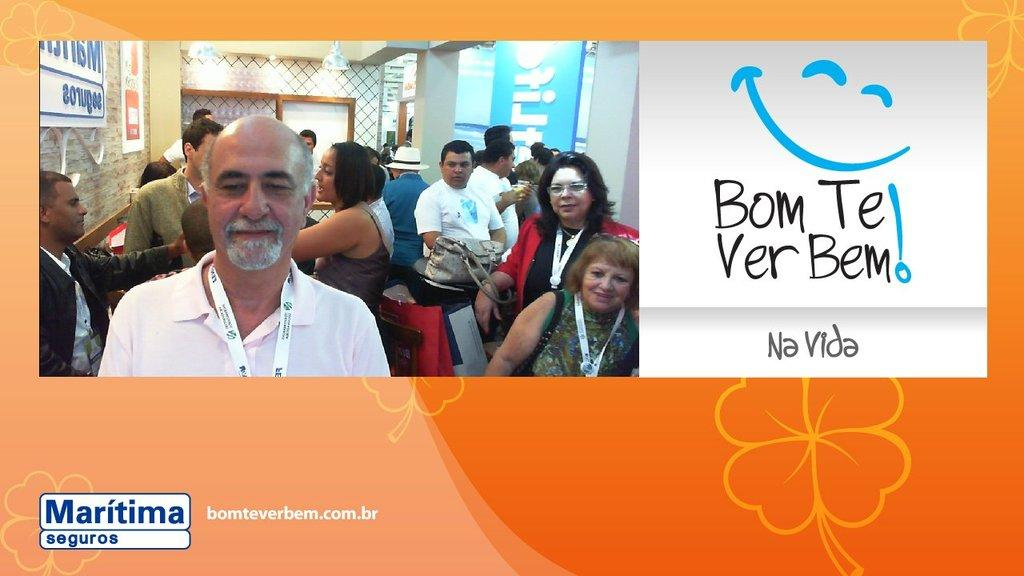What type of visual is the image? The image is a poster. What is happening in the poster? There is a group of people on the poster. Can you describe the actions of one person in the group? One person in the group is holding a bag. What can be seen in the background of the poster? There are boards, a pillar, lights, and a wall in the background of the poster. Can you tell me how many frogs are sitting on the pillar in the background of the poster? There are no frogs present in the image, and therefore no such activity can be observed. What color is the nose of the person holding the bag in the poster? The image does not show the nose of the person holding the bag, so it cannot be determined from the poster. 